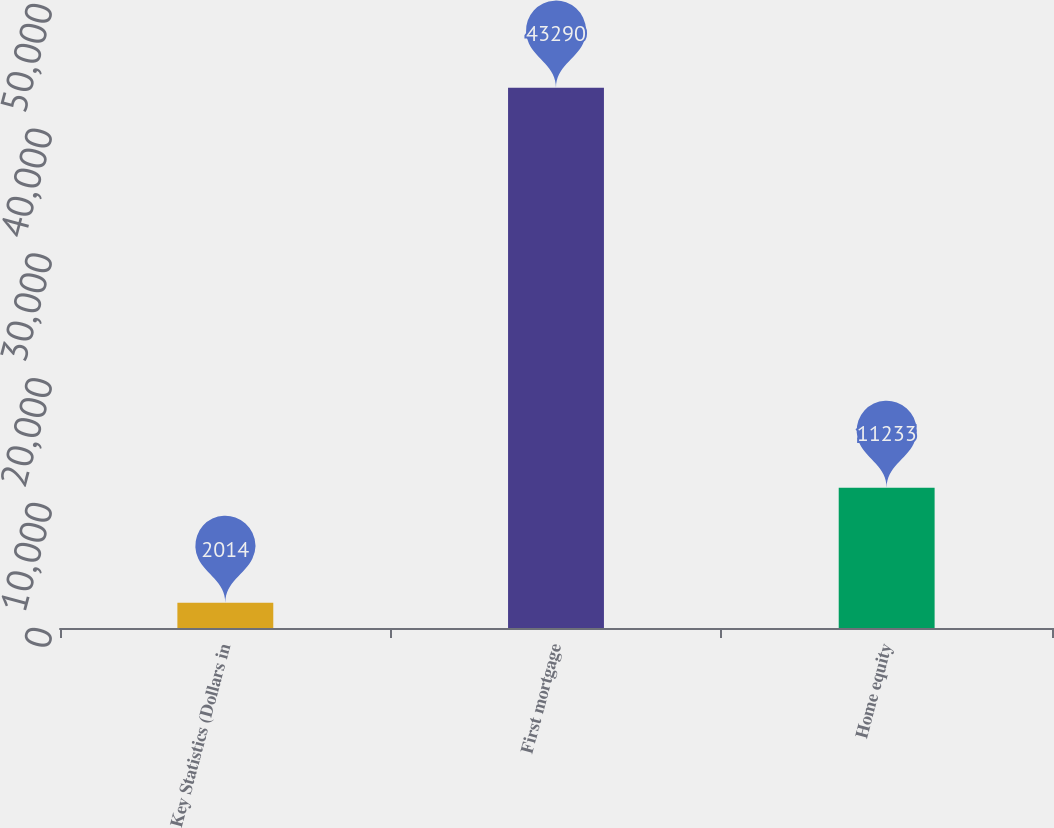Convert chart to OTSL. <chart><loc_0><loc_0><loc_500><loc_500><bar_chart><fcel>Key Statistics (Dollars in<fcel>First mortgage<fcel>Home equity<nl><fcel>2014<fcel>43290<fcel>11233<nl></chart> 